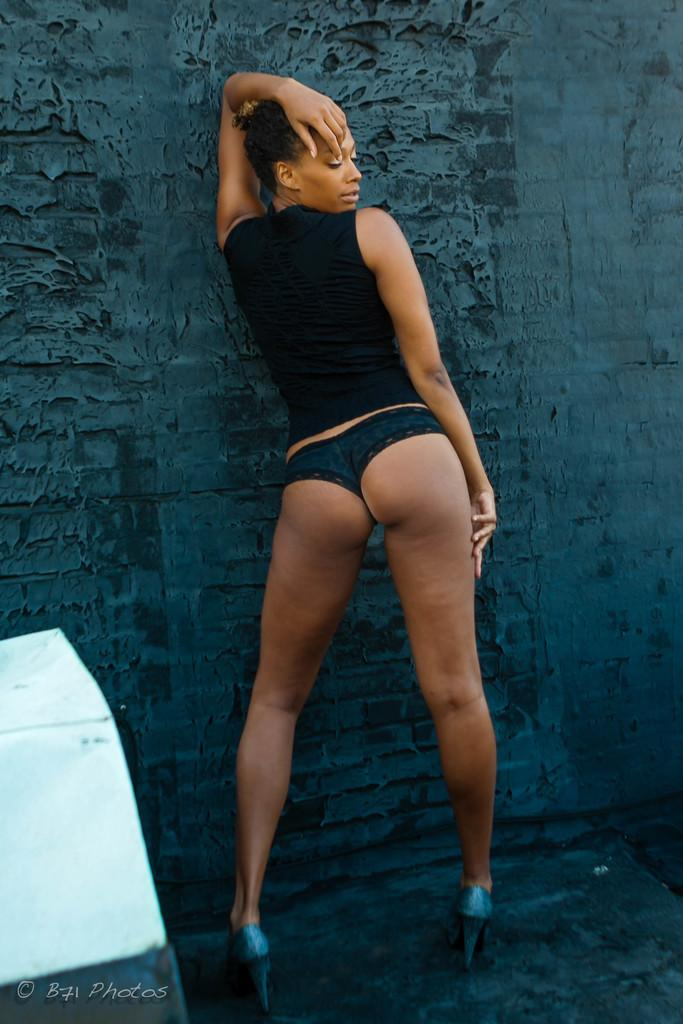What is the woman in the image doing? The facts do not specify what the woman is doing, but she is standing in the image. What color is the top the woman is wearing? The woman is wearing a black top. What can be seen on the floor on the left side of the image? There is an object on the floor on the left side of the image. What is visible in the background of the image? There is a wall in the background of the image. What arithmetic problem is the woman solving in the image? There is no indication in the image that the woman is solving an arithmetic problem. What type of cup is on the floor next to the object? There is no cup present in the image; only an object on the floor is mentioned. 